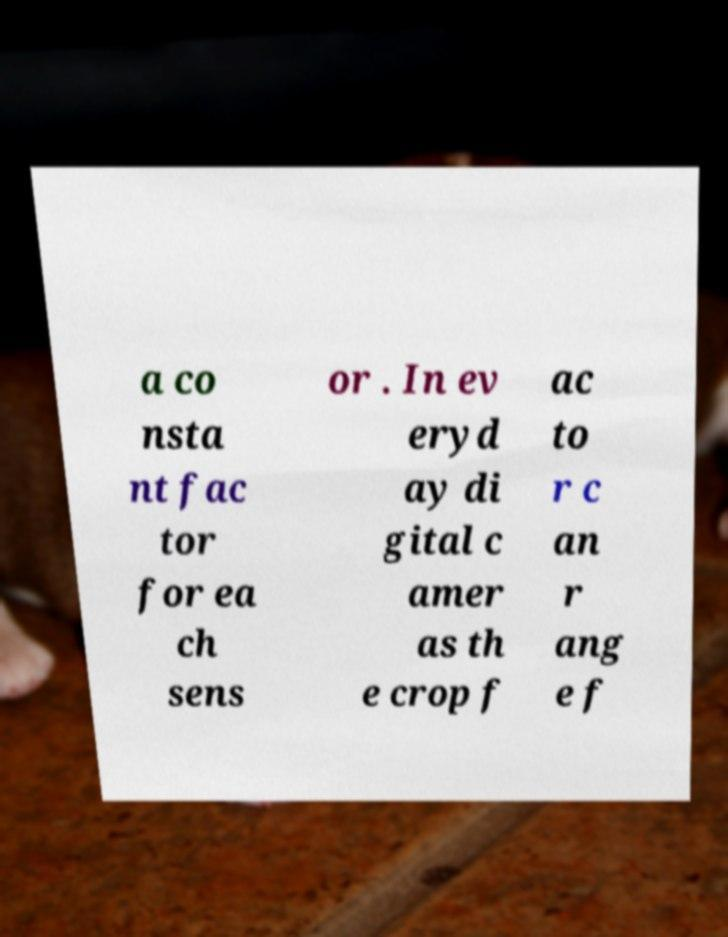Please read and relay the text visible in this image. What does it say? a co nsta nt fac tor for ea ch sens or . In ev eryd ay di gital c amer as th e crop f ac to r c an r ang e f 